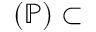<formula> <loc_0><loc_0><loc_500><loc_500>( \mathbb { P } ) \subset</formula> 